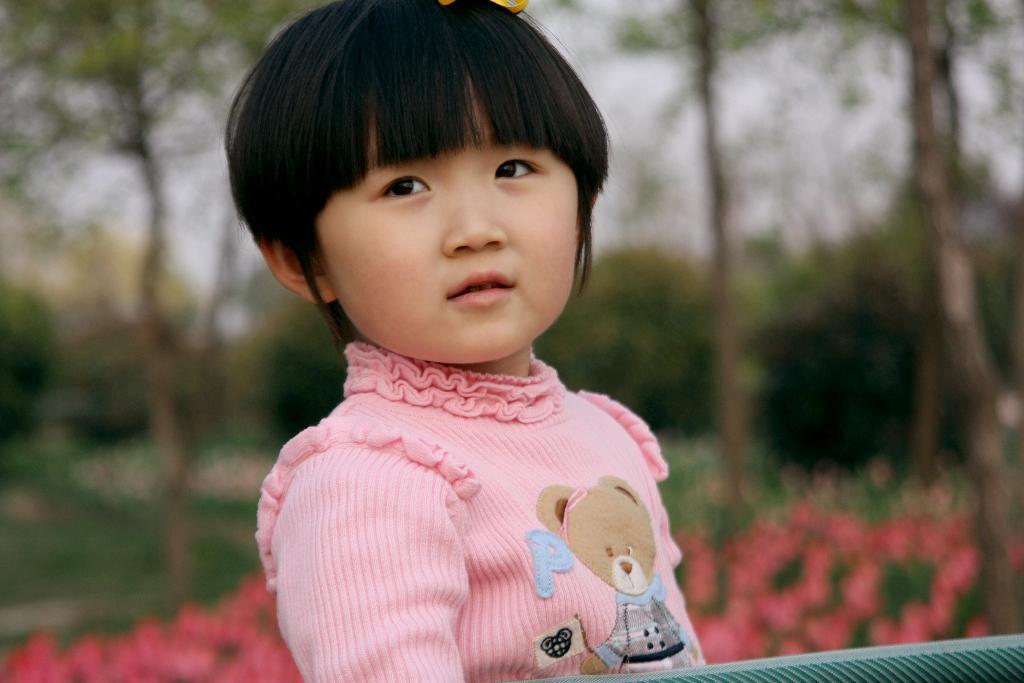Please provide a concise description of this image. In the front of the image there is a kid. In the background of the image is blurred. There are trees and flower plants. 